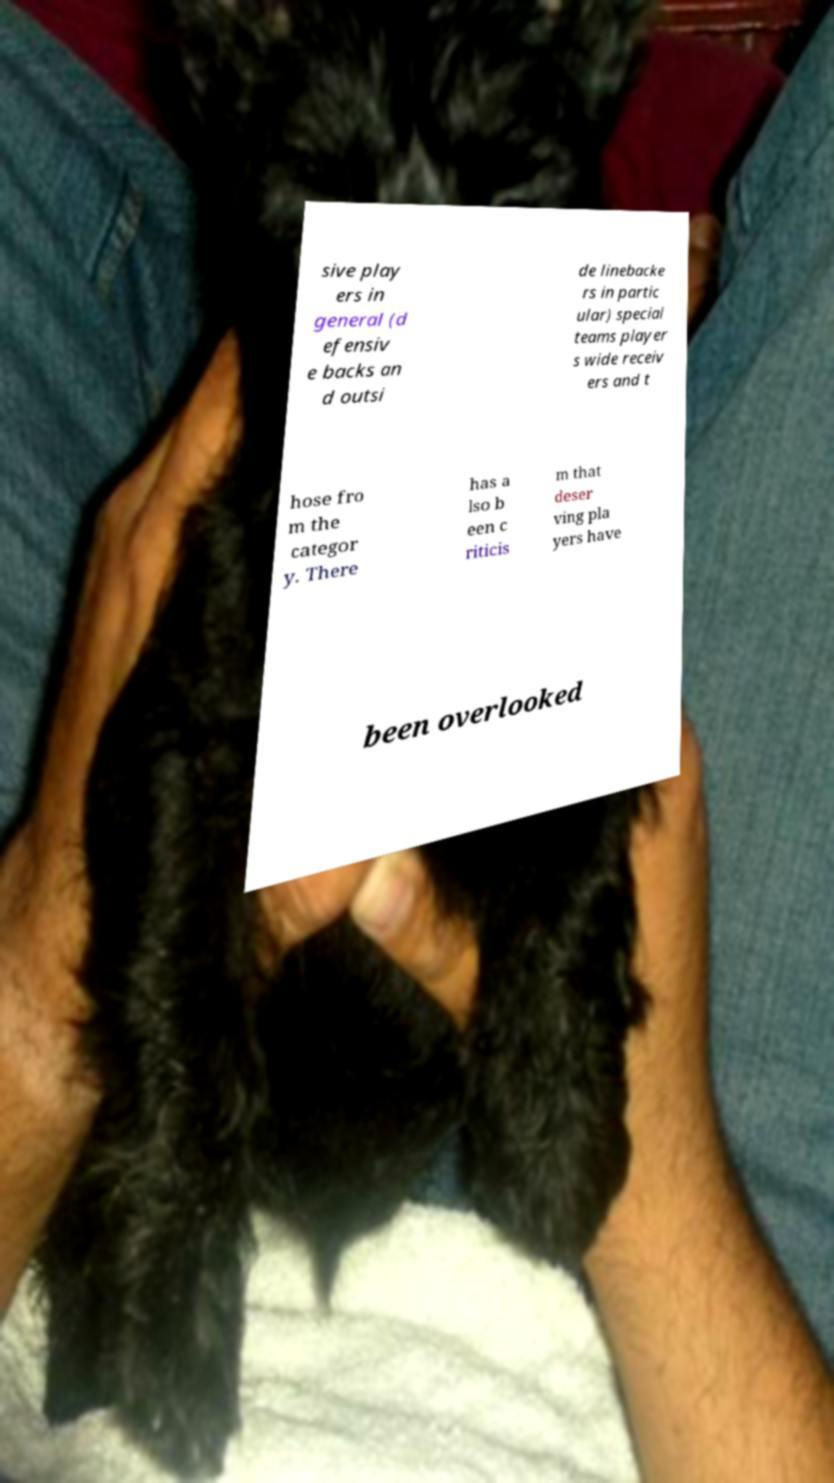Please identify and transcribe the text found in this image. sive play ers in general (d efensiv e backs an d outsi de linebacke rs in partic ular) special teams player s wide receiv ers and t hose fro m the categor y. There has a lso b een c riticis m that deser ving pla yers have been overlooked 